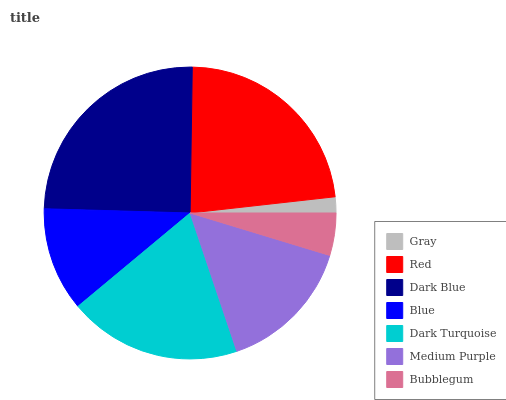Is Gray the minimum?
Answer yes or no. Yes. Is Dark Blue the maximum?
Answer yes or no. Yes. Is Red the minimum?
Answer yes or no. No. Is Red the maximum?
Answer yes or no. No. Is Red greater than Gray?
Answer yes or no. Yes. Is Gray less than Red?
Answer yes or no. Yes. Is Gray greater than Red?
Answer yes or no. No. Is Red less than Gray?
Answer yes or no. No. Is Medium Purple the high median?
Answer yes or no. Yes. Is Medium Purple the low median?
Answer yes or no. Yes. Is Dark Blue the high median?
Answer yes or no. No. Is Bubblegum the low median?
Answer yes or no. No. 